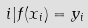<formula> <loc_0><loc_0><loc_500><loc_500>i | f ( x _ { i } ) = y _ { i }</formula> 